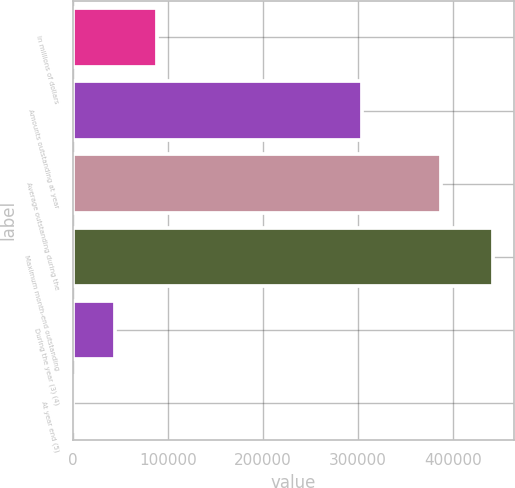<chart> <loc_0><loc_0><loc_500><loc_500><bar_chart><fcel>In millions of dollars<fcel>Amounts outstanding at year<fcel>Average outstanding during the<fcel>Maximum month-end outstanding<fcel>During the year (3) (4)<fcel>At year end (5)<nl><fcel>88372.4<fcel>304243<fcel>386628<fcel>441844<fcel>44188.5<fcel>4.52<nl></chart> 